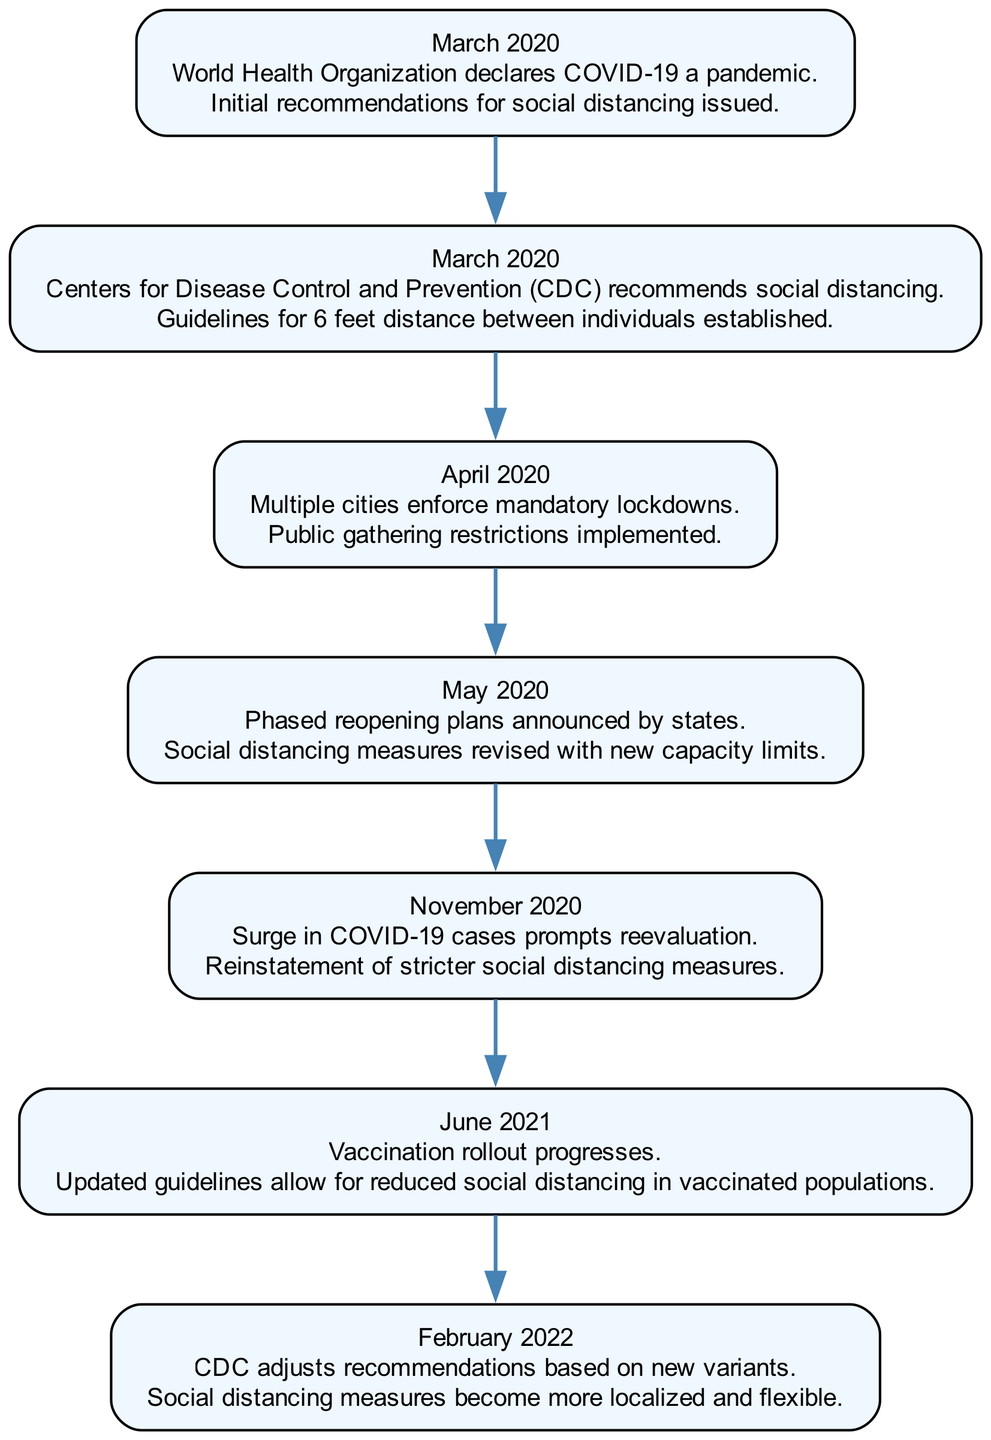What event occurred in March 2020? The diagram indicates that in March 2020, the World Health Organization declared COVID-19 a pandemic and the CDC recommended social distancing.
Answer: World Health Organization declares COVID-19 a pandemic What policy change was made in April 2020? According to the diagram, the event in April 2020 was the enforcement of mandatory lockdowns, which included public gathering restrictions.
Answer: Public gathering restrictions implemented How many total events are documented in the diagram? By counting the events listed, I see there are seven distinct events related to social distancing measures.
Answer: 7 What was a significant change made in February 2022? In February 2022, the CDC adjusted recommendations which led to social distancing measures becoming more localized and flexible.
Answer: Social distancing measures become more localized and flexible Which event led to the reinstatement of stricter measures? The diagram shows that a surge in COVID-19 cases in November 2020 prompted the reevaluation and reinstatement of stricter social distancing measures.
Answer: Surge in COVID-19 cases prompts reevaluation What do the arrows in the diagram indicate? The arrows in the sequence diagram indicate the chronological flow from one policy change to the next, showing how policies evolved over time.
Answer: Chronological flow of policy changes What new guideline was established by the CDC in March 2020? The CDC's recommendation in March 2020 included establishing guidelines for maintaining a distance of 6 feet between individuals.
Answer: Guidelines for 6 feet distance How did the social distancing measures change post-vaccination in June 2021? The updated guidelines in June 2021 allowed for reduced social distancing in vaccinated populations, indicating a shift in approach based on vaccination status.
Answer: Reduced social distancing in vaccinated populations 